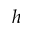<formula> <loc_0><loc_0><loc_500><loc_500>h</formula> 